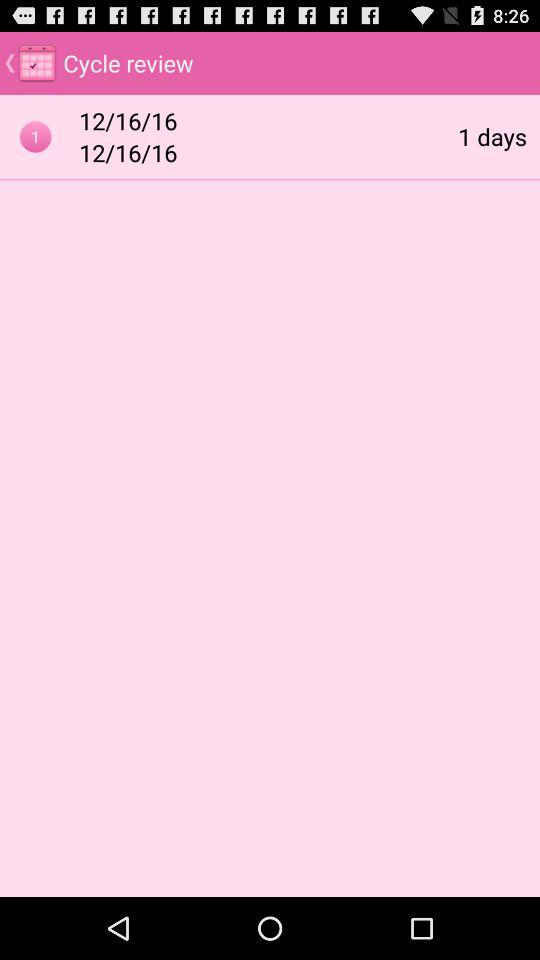How many days is the Cycle review going to last?
Answer the question using a single word or phrase. 1 